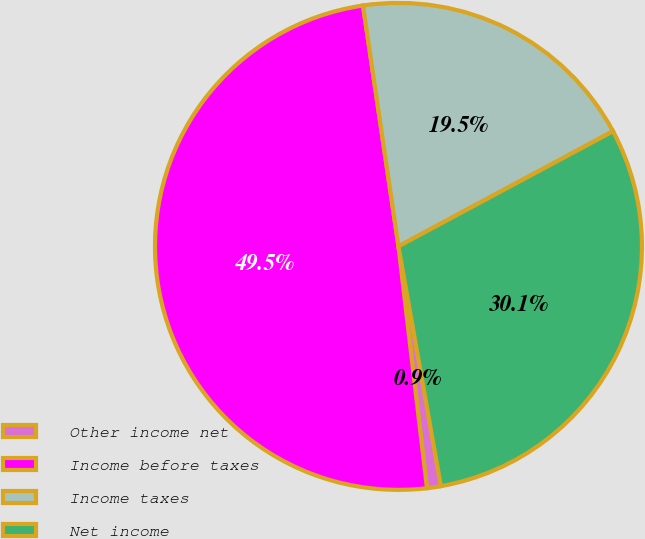Convert chart to OTSL. <chart><loc_0><loc_0><loc_500><loc_500><pie_chart><fcel>Other income net<fcel>Income before taxes<fcel>Income taxes<fcel>Net income<nl><fcel>0.92%<fcel>49.54%<fcel>19.49%<fcel>30.05%<nl></chart> 